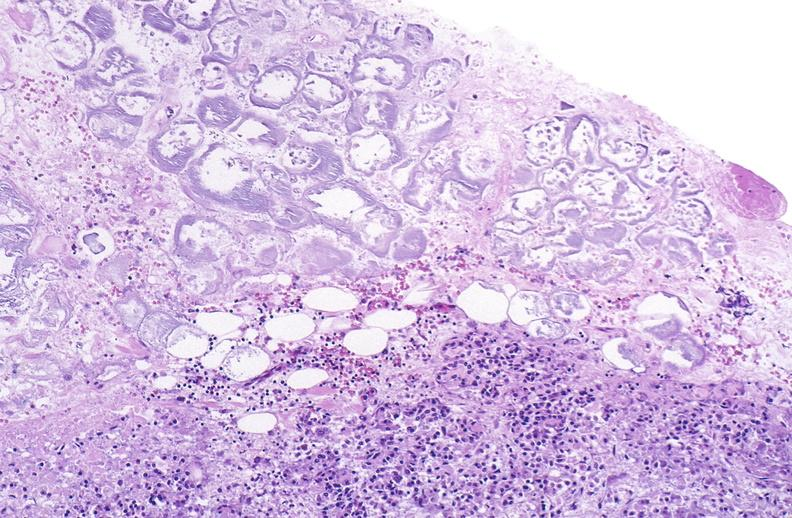does rocky mountain show pancreatic fat necrosis?
Answer the question using a single word or phrase. No 